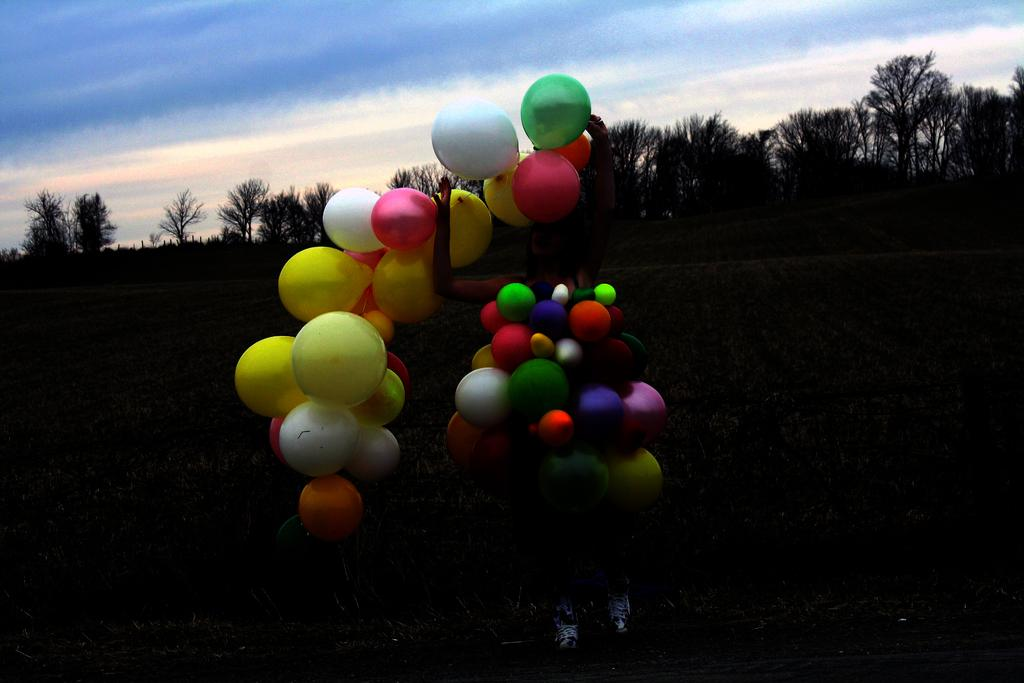What is the main subject of the image? There is a person in the image. What is the person holding in the image? The person is holding balloons. What type of surface is visible in the image? There is ground visible in the image. What type of vegetation can be seen in the image? There are trees in the image. What part of the natural environment is visible in the image? The sky is visible in the image. What can be observed in the sky? Clouds are present in the sky. What type of voyage is the person embarking on in the image? There is no indication of a voyage in the image; it simply shows a person holding balloons. What kind of flame can be seen near the person in the image? There is no flame present in the image. 